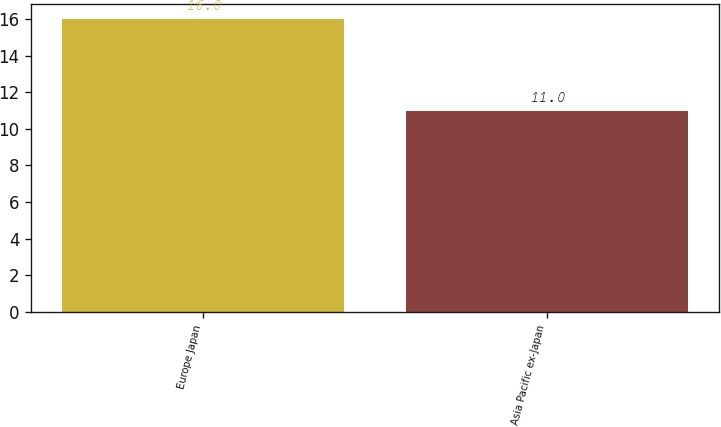Convert chart to OTSL. <chart><loc_0><loc_0><loc_500><loc_500><bar_chart><fcel>Europe Japan<fcel>Asia Pacific ex-Japan<nl><fcel>16<fcel>11<nl></chart> 